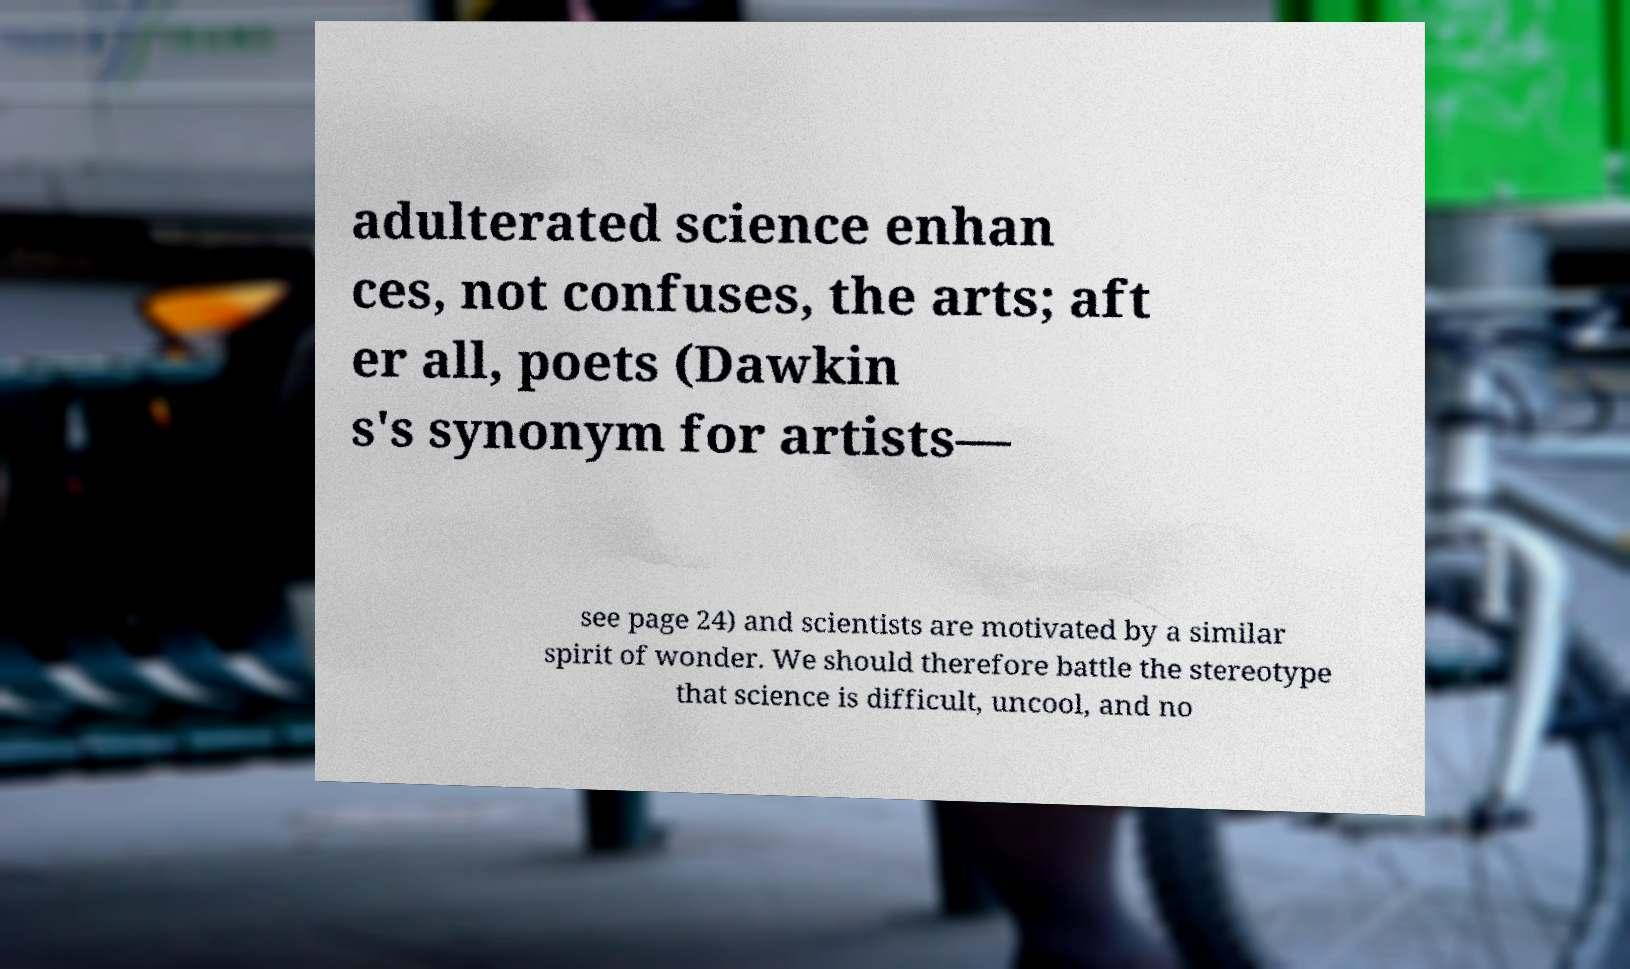I need the written content from this picture converted into text. Can you do that? adulterated science enhan ces, not confuses, the arts; aft er all, poets (Dawkin s's synonym for artists— see page 24) and scientists are motivated by a similar spirit of wonder. We should therefore battle the stereotype that science is difficult, uncool, and no 